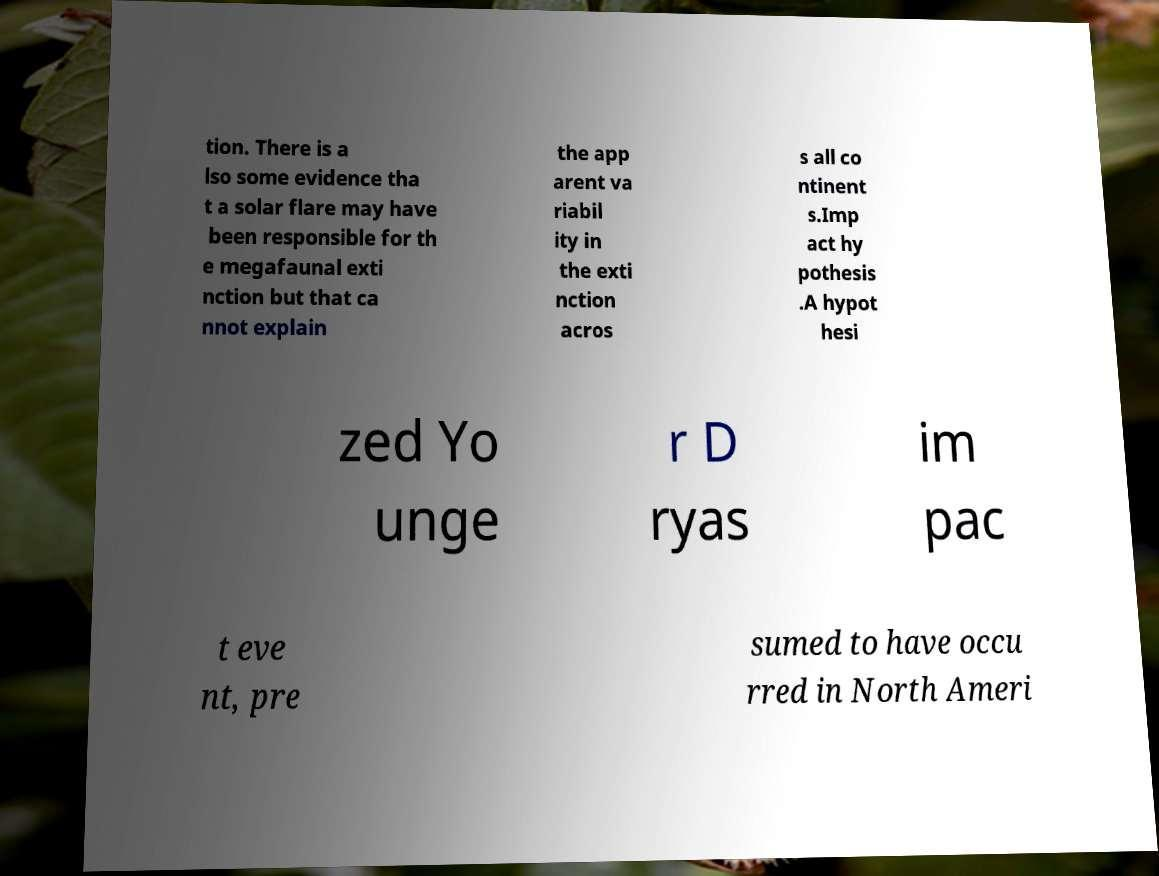Please read and relay the text visible in this image. What does it say? tion. There is a lso some evidence tha t a solar flare may have been responsible for th e megafaunal exti nction but that ca nnot explain the app arent va riabil ity in the exti nction acros s all co ntinent s.Imp act hy pothesis .A hypot hesi zed Yo unge r D ryas im pac t eve nt, pre sumed to have occu rred in North Ameri 